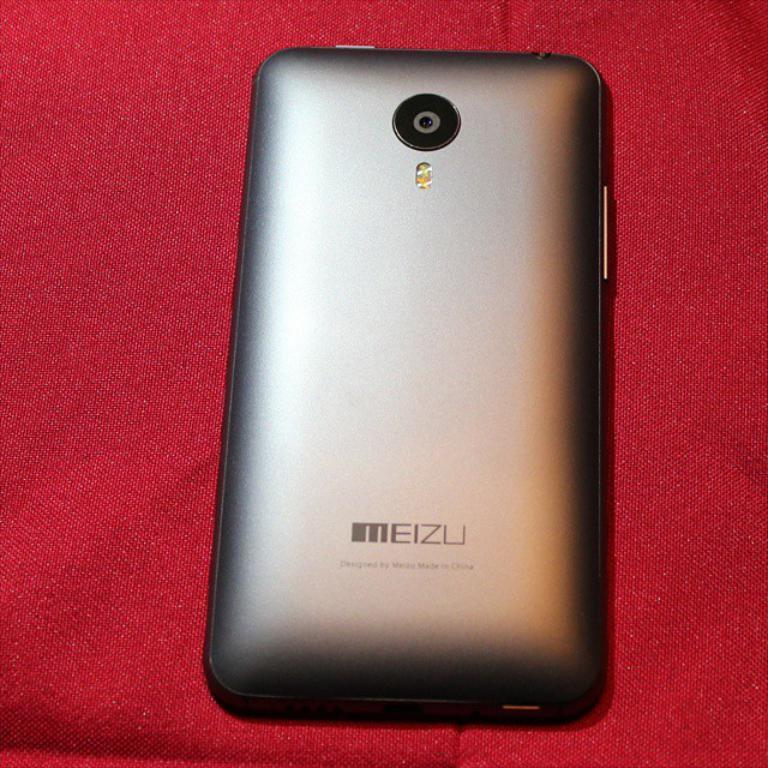Provide a one-sentence caption for the provided image. the back of a MEIZU cell phone on a red backdrop. 